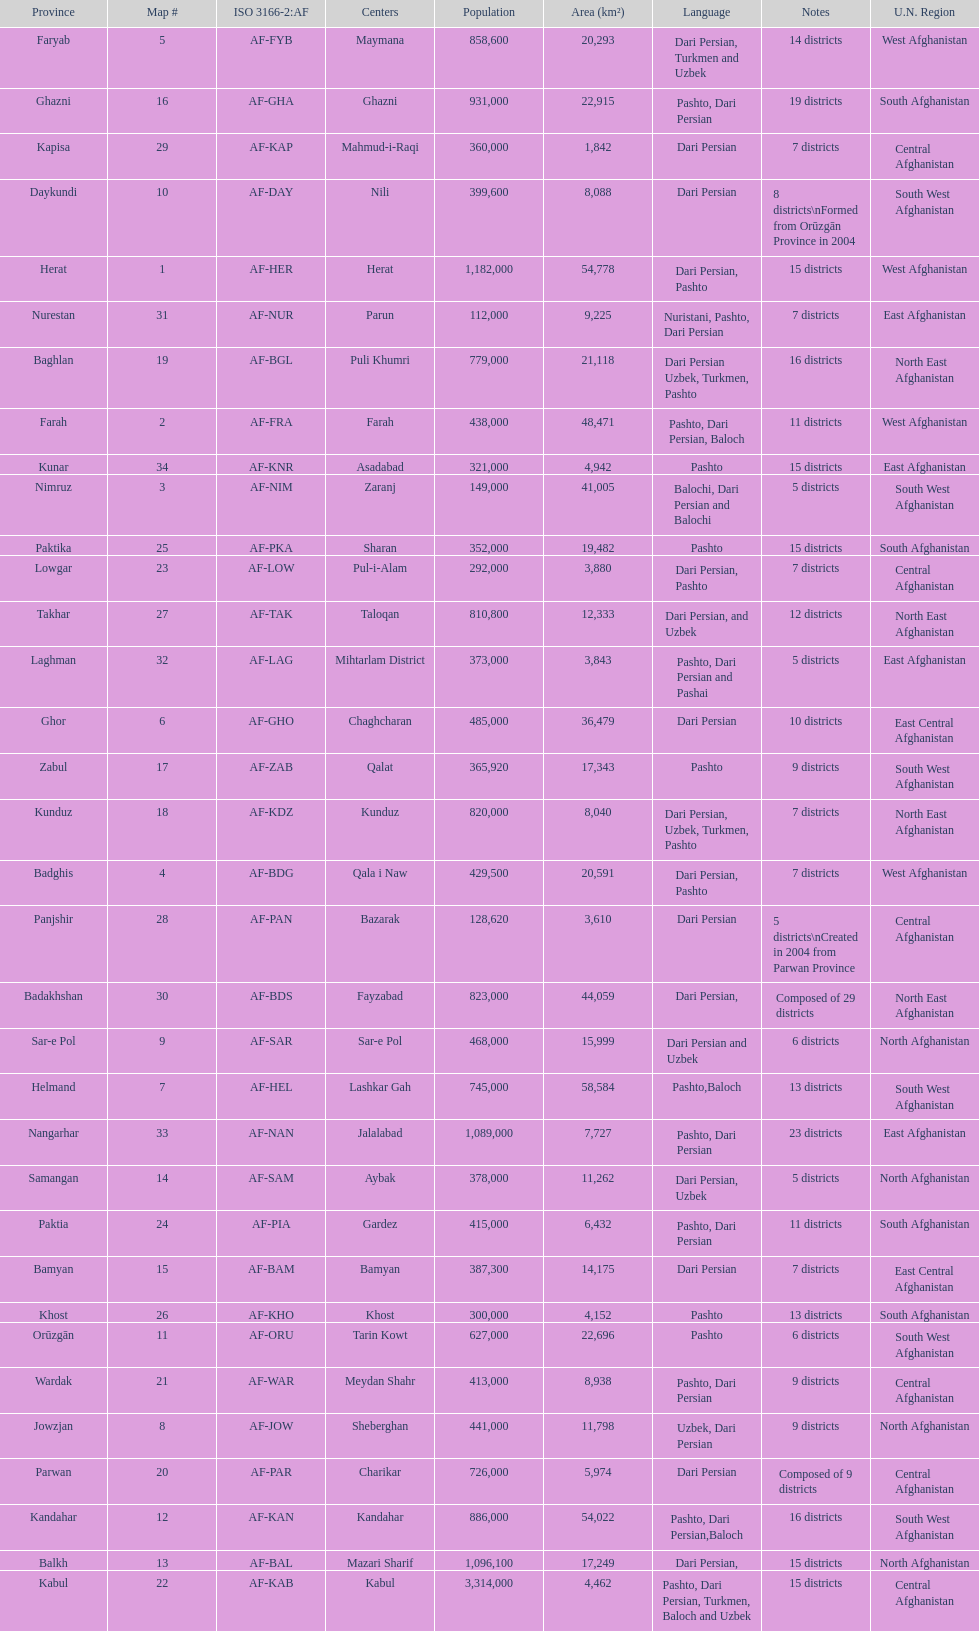Herat has a population of 1,182,000, can you list their languages Dari Persian, Pashto. 